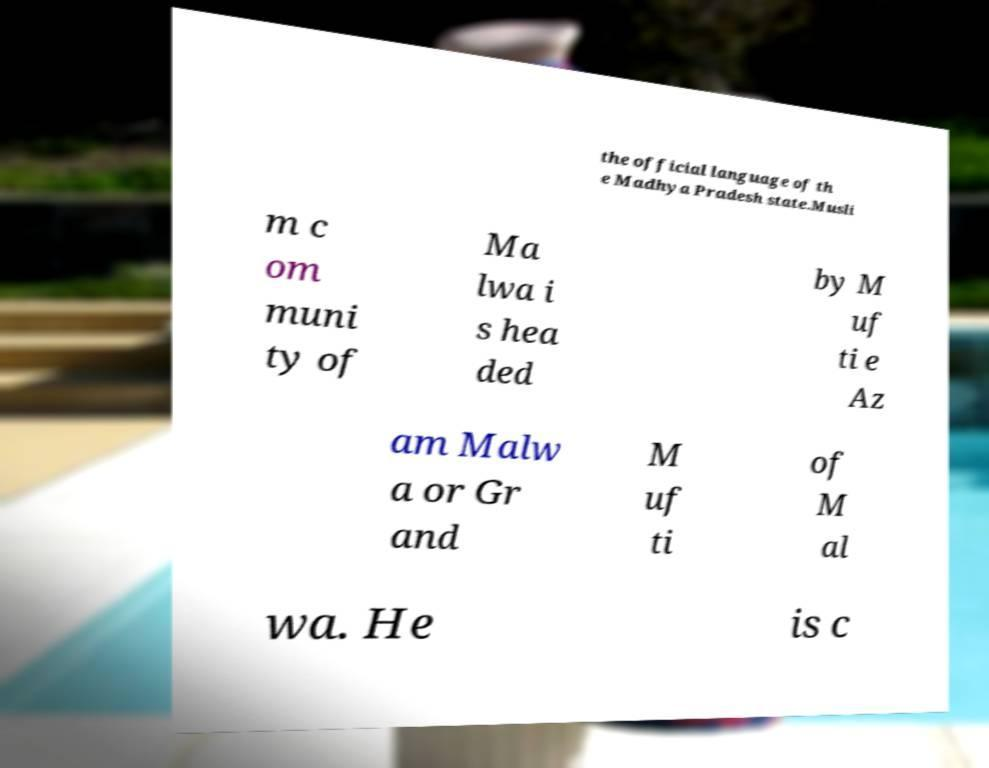Could you assist in decoding the text presented in this image and type it out clearly? the official language of th e Madhya Pradesh state.Musli m c om muni ty of Ma lwa i s hea ded by M uf ti e Az am Malw a or Gr and M uf ti of M al wa. He is c 